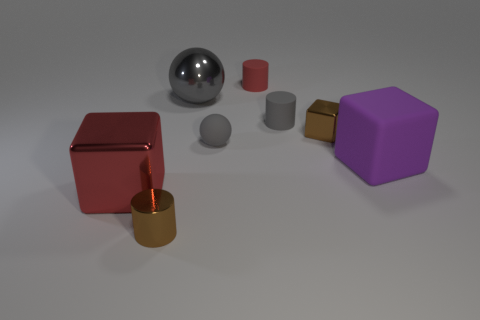Add 1 green matte cylinders. How many objects exist? 9 Subtract all cubes. How many objects are left? 5 Subtract all large red balls. Subtract all gray rubber balls. How many objects are left? 7 Add 8 gray matte cylinders. How many gray matte cylinders are left? 9 Add 6 tiny red metallic balls. How many tiny red metallic balls exist? 6 Subtract 0 green spheres. How many objects are left? 8 